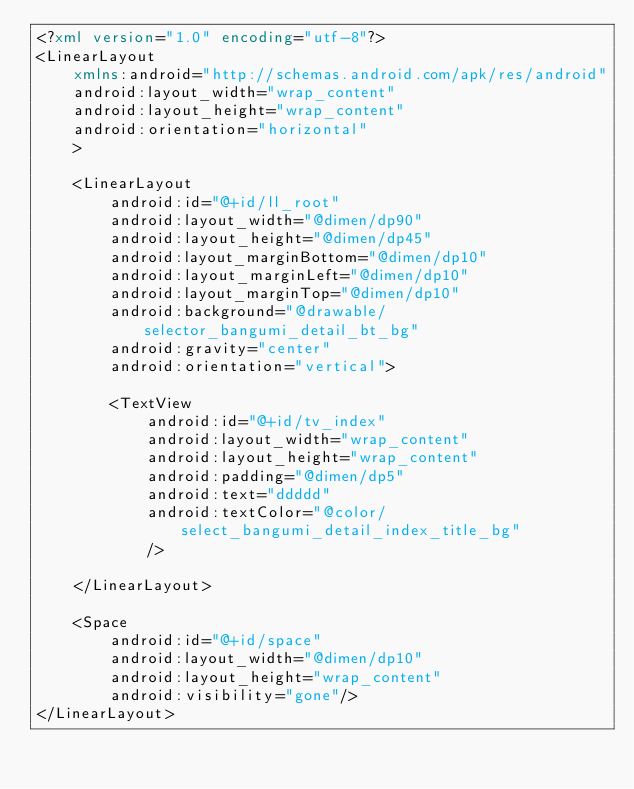Convert code to text. <code><loc_0><loc_0><loc_500><loc_500><_XML_><?xml version="1.0" encoding="utf-8"?>
<LinearLayout
    xmlns:android="http://schemas.android.com/apk/res/android"
    android:layout_width="wrap_content"
    android:layout_height="wrap_content"
    android:orientation="horizontal"
    >

    <LinearLayout
        android:id="@+id/ll_root"
        android:layout_width="@dimen/dp90"
        android:layout_height="@dimen/dp45"
        android:layout_marginBottom="@dimen/dp10"
        android:layout_marginLeft="@dimen/dp10"
        android:layout_marginTop="@dimen/dp10"
        android:background="@drawable/selector_bangumi_detail_bt_bg"
        android:gravity="center"
        android:orientation="vertical">

        <TextView
            android:id="@+id/tv_index"
            android:layout_width="wrap_content"
            android:layout_height="wrap_content"
            android:padding="@dimen/dp5"
            android:text="ddddd"
            android:textColor="@color/select_bangumi_detail_index_title_bg"
            />

    </LinearLayout>

    <Space
        android:id="@+id/space"
        android:layout_width="@dimen/dp10"
        android:layout_height="wrap_content"
        android:visibility="gone"/>
</LinearLayout></code> 